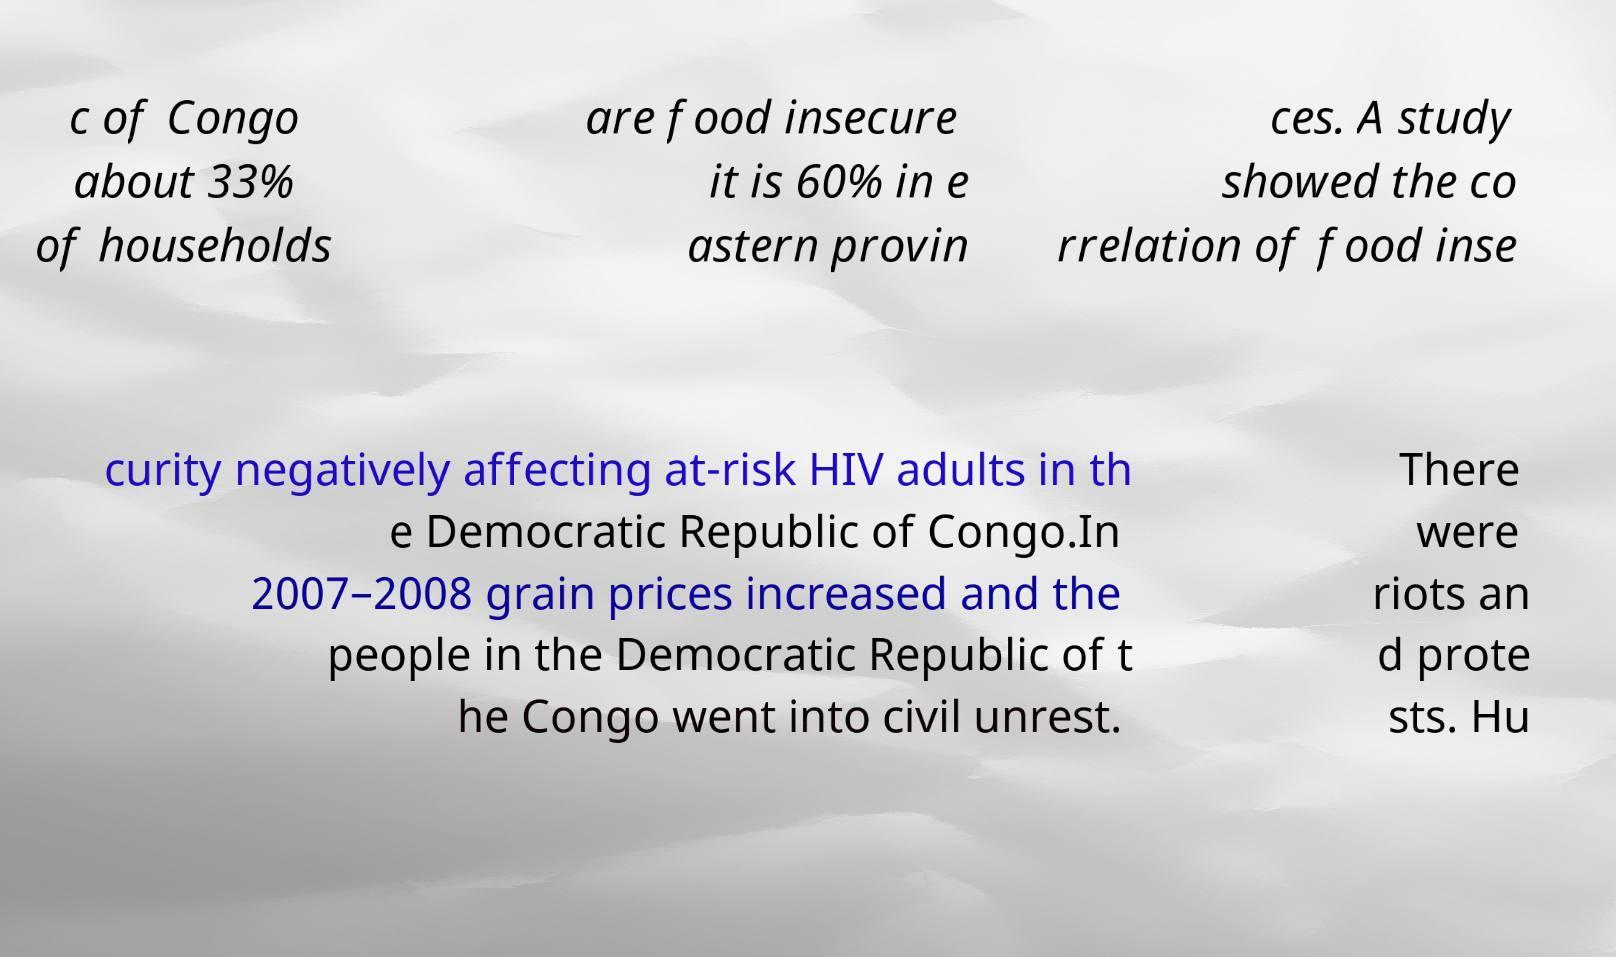What messages or text are displayed in this image? I need them in a readable, typed format. c of Congo about 33% of households are food insecure it is 60% in e astern provin ces. A study showed the co rrelation of food inse curity negatively affecting at-risk HIV adults in th e Democratic Republic of Congo.In 2007–2008 grain prices increased and the people in the Democratic Republic of t he Congo went into civil unrest. There were riots an d prote sts. Hu 